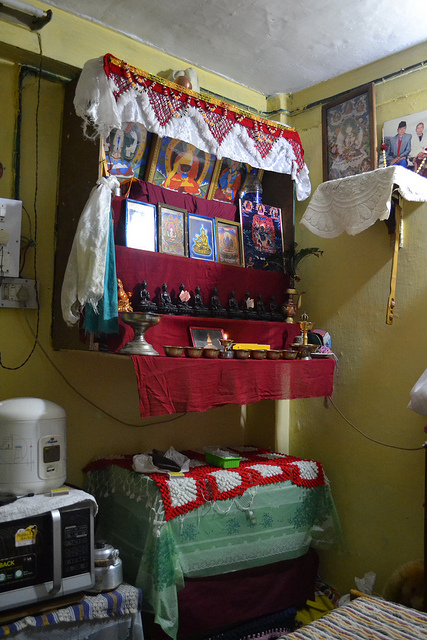<image>What pastel color is the long cloth on top of the table? I don't know the exact color of the long cloth on top of the table. It could be green, red, or teal. What pastel color is the long cloth on top of the table? I don't know the pastel color of the long cloth on top of the table. It can be seen as green, red or teal. 